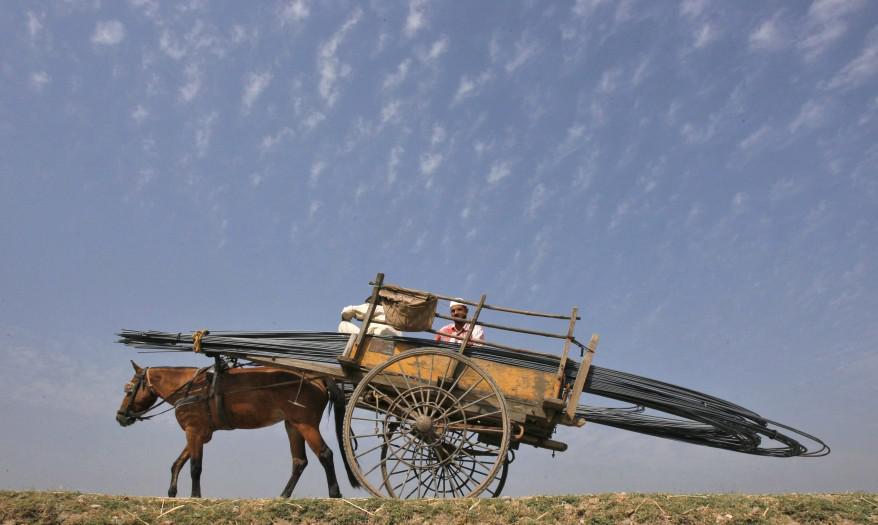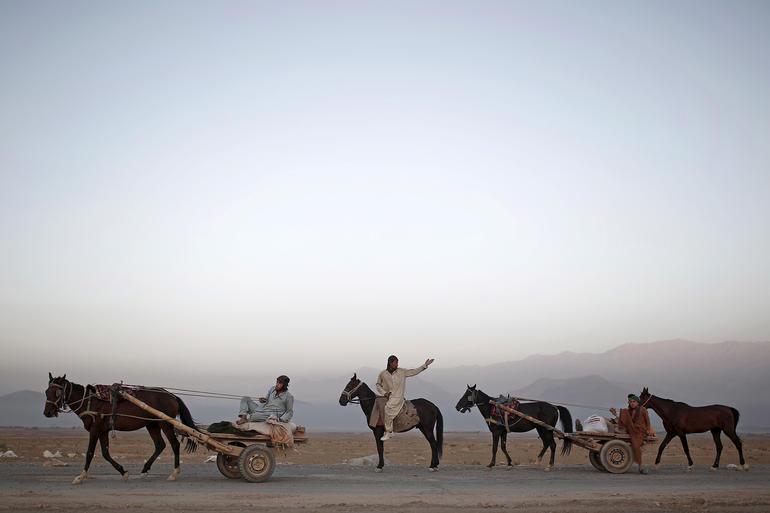The first image is the image on the left, the second image is the image on the right. For the images shown, is this caption "There are three or more horses in at least one image." true? Answer yes or no. Yes. The first image is the image on the left, the second image is the image on the right. Given the left and right images, does the statement "Has atleast one image with more than 3 horses" hold true? Answer yes or no. Yes. 